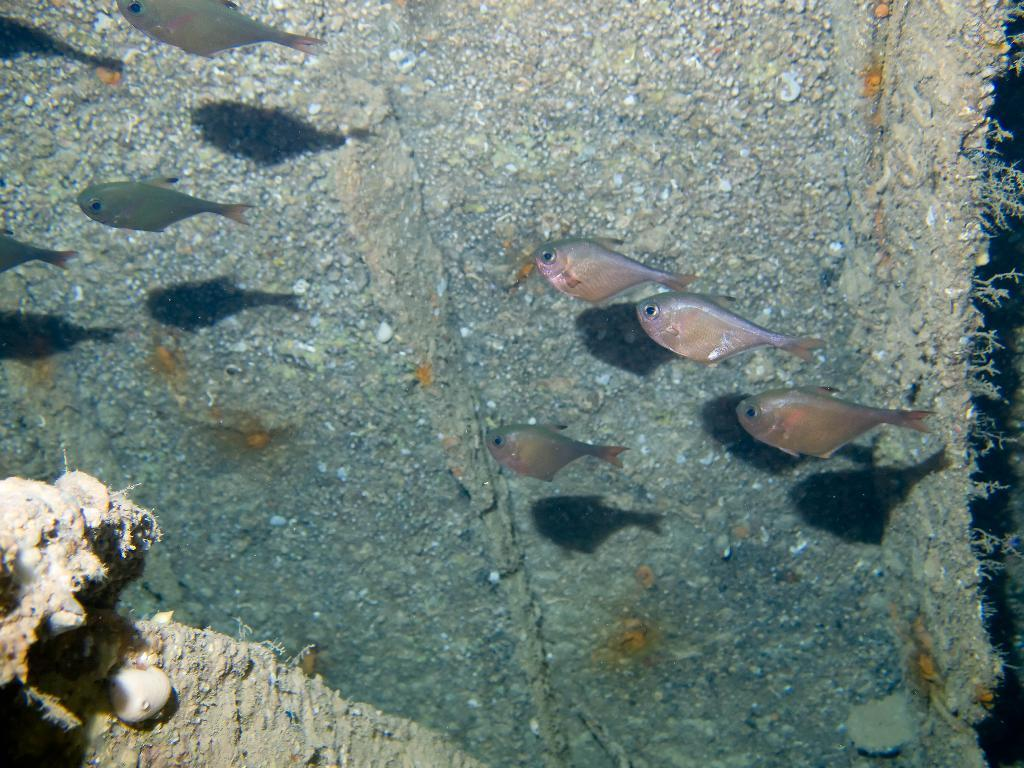What type of animals are in the image? There are fishes in the image. Where are the fishes located? The fishes are in the water. What type of plants can be seen growing on the clocks in the image? There are no clocks or plants present in the image; it features fishes in the water. 